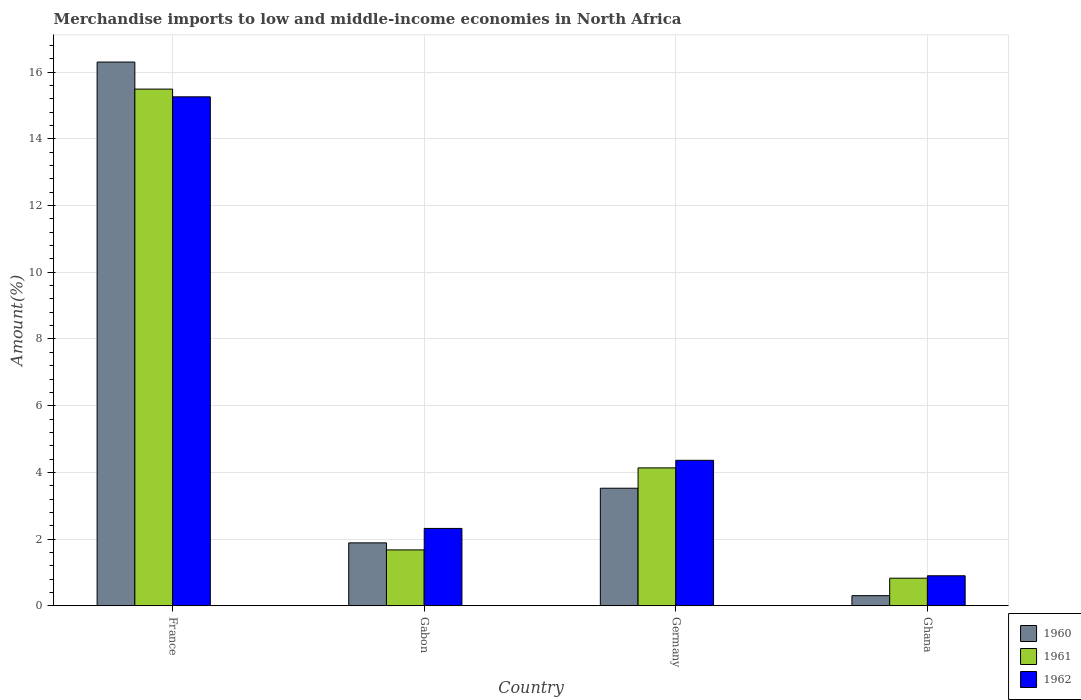How many groups of bars are there?
Provide a short and direct response. 4. Are the number of bars on each tick of the X-axis equal?
Keep it short and to the point. Yes. What is the label of the 2nd group of bars from the left?
Your response must be concise. Gabon. In how many cases, is the number of bars for a given country not equal to the number of legend labels?
Your response must be concise. 0. What is the percentage of amount earned from merchandise imports in 1962 in France?
Offer a terse response. 15.26. Across all countries, what is the maximum percentage of amount earned from merchandise imports in 1962?
Your answer should be compact. 15.26. Across all countries, what is the minimum percentage of amount earned from merchandise imports in 1960?
Ensure brevity in your answer.  0.3. In which country was the percentage of amount earned from merchandise imports in 1962 minimum?
Make the answer very short. Ghana. What is the total percentage of amount earned from merchandise imports in 1960 in the graph?
Make the answer very short. 22.02. What is the difference between the percentage of amount earned from merchandise imports in 1960 in Gabon and that in Ghana?
Offer a terse response. 1.58. What is the difference between the percentage of amount earned from merchandise imports in 1960 in Gabon and the percentage of amount earned from merchandise imports in 1961 in France?
Make the answer very short. -13.61. What is the average percentage of amount earned from merchandise imports in 1960 per country?
Give a very brief answer. 5.51. What is the difference between the percentage of amount earned from merchandise imports of/in 1960 and percentage of amount earned from merchandise imports of/in 1962 in Gabon?
Your answer should be compact. -0.43. In how many countries, is the percentage of amount earned from merchandise imports in 1960 greater than 14.4 %?
Ensure brevity in your answer.  1. What is the ratio of the percentage of amount earned from merchandise imports in 1960 in France to that in Germany?
Give a very brief answer. 4.62. Is the percentage of amount earned from merchandise imports in 1961 in France less than that in Ghana?
Ensure brevity in your answer.  No. What is the difference between the highest and the second highest percentage of amount earned from merchandise imports in 1961?
Your response must be concise. -2.46. What is the difference between the highest and the lowest percentage of amount earned from merchandise imports in 1960?
Provide a short and direct response. 16. In how many countries, is the percentage of amount earned from merchandise imports in 1962 greater than the average percentage of amount earned from merchandise imports in 1962 taken over all countries?
Offer a terse response. 1. Is the sum of the percentage of amount earned from merchandise imports in 1960 in France and Germany greater than the maximum percentage of amount earned from merchandise imports in 1961 across all countries?
Make the answer very short. Yes. What does the 3rd bar from the left in France represents?
Your answer should be compact. 1962. What does the 3rd bar from the right in Germany represents?
Keep it short and to the point. 1960. How many bars are there?
Your response must be concise. 12. How many countries are there in the graph?
Offer a terse response. 4. Are the values on the major ticks of Y-axis written in scientific E-notation?
Your response must be concise. No. Does the graph contain any zero values?
Your answer should be compact. No. Does the graph contain grids?
Your answer should be very brief. Yes. How are the legend labels stacked?
Your response must be concise. Vertical. What is the title of the graph?
Offer a very short reply. Merchandise imports to low and middle-income economies in North Africa. What is the label or title of the X-axis?
Your answer should be compact. Country. What is the label or title of the Y-axis?
Give a very brief answer. Amount(%). What is the Amount(%) of 1960 in France?
Keep it short and to the point. 16.3. What is the Amount(%) of 1961 in France?
Ensure brevity in your answer.  15.49. What is the Amount(%) in 1962 in France?
Your answer should be very brief. 15.26. What is the Amount(%) of 1960 in Gabon?
Keep it short and to the point. 1.89. What is the Amount(%) in 1961 in Gabon?
Your response must be concise. 1.68. What is the Amount(%) in 1962 in Gabon?
Your answer should be compact. 2.32. What is the Amount(%) of 1960 in Germany?
Make the answer very short. 3.53. What is the Amount(%) in 1961 in Germany?
Keep it short and to the point. 4.14. What is the Amount(%) of 1962 in Germany?
Keep it short and to the point. 4.36. What is the Amount(%) in 1960 in Ghana?
Offer a very short reply. 0.3. What is the Amount(%) in 1961 in Ghana?
Your answer should be very brief. 0.83. What is the Amount(%) in 1962 in Ghana?
Keep it short and to the point. 0.9. Across all countries, what is the maximum Amount(%) of 1960?
Provide a short and direct response. 16.3. Across all countries, what is the maximum Amount(%) of 1961?
Give a very brief answer. 15.49. Across all countries, what is the maximum Amount(%) of 1962?
Your answer should be compact. 15.26. Across all countries, what is the minimum Amount(%) in 1960?
Your answer should be very brief. 0.3. Across all countries, what is the minimum Amount(%) in 1961?
Make the answer very short. 0.83. Across all countries, what is the minimum Amount(%) of 1962?
Keep it short and to the point. 0.9. What is the total Amount(%) in 1960 in the graph?
Offer a very short reply. 22.02. What is the total Amount(%) of 1961 in the graph?
Keep it short and to the point. 22.13. What is the total Amount(%) of 1962 in the graph?
Make the answer very short. 22.84. What is the difference between the Amount(%) in 1960 in France and that in Gabon?
Offer a terse response. 14.42. What is the difference between the Amount(%) of 1961 in France and that in Gabon?
Make the answer very short. 13.82. What is the difference between the Amount(%) in 1962 in France and that in Gabon?
Your answer should be very brief. 12.94. What is the difference between the Amount(%) of 1960 in France and that in Germany?
Keep it short and to the point. 12.78. What is the difference between the Amount(%) of 1961 in France and that in Germany?
Offer a terse response. 11.36. What is the difference between the Amount(%) of 1962 in France and that in Germany?
Make the answer very short. 10.9. What is the difference between the Amount(%) of 1960 in France and that in Ghana?
Your answer should be compact. 16. What is the difference between the Amount(%) in 1961 in France and that in Ghana?
Provide a succinct answer. 14.67. What is the difference between the Amount(%) of 1962 in France and that in Ghana?
Your response must be concise. 14.36. What is the difference between the Amount(%) of 1960 in Gabon and that in Germany?
Provide a succinct answer. -1.64. What is the difference between the Amount(%) in 1961 in Gabon and that in Germany?
Provide a succinct answer. -2.46. What is the difference between the Amount(%) in 1962 in Gabon and that in Germany?
Your answer should be very brief. -2.04. What is the difference between the Amount(%) of 1960 in Gabon and that in Ghana?
Your answer should be compact. 1.58. What is the difference between the Amount(%) in 1961 in Gabon and that in Ghana?
Your answer should be very brief. 0.85. What is the difference between the Amount(%) in 1962 in Gabon and that in Ghana?
Provide a short and direct response. 1.42. What is the difference between the Amount(%) of 1960 in Germany and that in Ghana?
Keep it short and to the point. 3.22. What is the difference between the Amount(%) in 1961 in Germany and that in Ghana?
Your response must be concise. 3.31. What is the difference between the Amount(%) in 1962 in Germany and that in Ghana?
Offer a terse response. 3.46. What is the difference between the Amount(%) in 1960 in France and the Amount(%) in 1961 in Gabon?
Keep it short and to the point. 14.63. What is the difference between the Amount(%) in 1960 in France and the Amount(%) in 1962 in Gabon?
Give a very brief answer. 13.98. What is the difference between the Amount(%) of 1961 in France and the Amount(%) of 1962 in Gabon?
Ensure brevity in your answer.  13.17. What is the difference between the Amount(%) of 1960 in France and the Amount(%) of 1961 in Germany?
Give a very brief answer. 12.17. What is the difference between the Amount(%) of 1960 in France and the Amount(%) of 1962 in Germany?
Offer a very short reply. 11.94. What is the difference between the Amount(%) in 1961 in France and the Amount(%) in 1962 in Germany?
Give a very brief answer. 11.13. What is the difference between the Amount(%) in 1960 in France and the Amount(%) in 1961 in Ghana?
Provide a succinct answer. 15.48. What is the difference between the Amount(%) in 1960 in France and the Amount(%) in 1962 in Ghana?
Make the answer very short. 15.4. What is the difference between the Amount(%) of 1961 in France and the Amount(%) of 1962 in Ghana?
Ensure brevity in your answer.  14.59. What is the difference between the Amount(%) in 1960 in Gabon and the Amount(%) in 1961 in Germany?
Offer a terse response. -2.25. What is the difference between the Amount(%) of 1960 in Gabon and the Amount(%) of 1962 in Germany?
Keep it short and to the point. -2.48. What is the difference between the Amount(%) in 1961 in Gabon and the Amount(%) in 1962 in Germany?
Give a very brief answer. -2.69. What is the difference between the Amount(%) of 1960 in Gabon and the Amount(%) of 1961 in Ghana?
Give a very brief answer. 1.06. What is the difference between the Amount(%) in 1960 in Gabon and the Amount(%) in 1962 in Ghana?
Your answer should be compact. 0.99. What is the difference between the Amount(%) in 1961 in Gabon and the Amount(%) in 1962 in Ghana?
Ensure brevity in your answer.  0.78. What is the difference between the Amount(%) of 1960 in Germany and the Amount(%) of 1961 in Ghana?
Provide a succinct answer. 2.7. What is the difference between the Amount(%) of 1960 in Germany and the Amount(%) of 1962 in Ghana?
Your answer should be compact. 2.63. What is the difference between the Amount(%) of 1961 in Germany and the Amount(%) of 1962 in Ghana?
Your answer should be very brief. 3.23. What is the average Amount(%) of 1960 per country?
Offer a very short reply. 5.5. What is the average Amount(%) in 1961 per country?
Give a very brief answer. 5.53. What is the average Amount(%) in 1962 per country?
Offer a very short reply. 5.71. What is the difference between the Amount(%) in 1960 and Amount(%) in 1961 in France?
Ensure brevity in your answer.  0.81. What is the difference between the Amount(%) of 1960 and Amount(%) of 1962 in France?
Keep it short and to the point. 1.04. What is the difference between the Amount(%) of 1961 and Amount(%) of 1962 in France?
Provide a short and direct response. 0.23. What is the difference between the Amount(%) in 1960 and Amount(%) in 1961 in Gabon?
Offer a terse response. 0.21. What is the difference between the Amount(%) of 1960 and Amount(%) of 1962 in Gabon?
Provide a short and direct response. -0.43. What is the difference between the Amount(%) of 1961 and Amount(%) of 1962 in Gabon?
Your answer should be compact. -0.64. What is the difference between the Amount(%) in 1960 and Amount(%) in 1961 in Germany?
Keep it short and to the point. -0.61. What is the difference between the Amount(%) in 1960 and Amount(%) in 1962 in Germany?
Keep it short and to the point. -0.84. What is the difference between the Amount(%) of 1961 and Amount(%) of 1962 in Germany?
Offer a very short reply. -0.23. What is the difference between the Amount(%) of 1960 and Amount(%) of 1961 in Ghana?
Give a very brief answer. -0.52. What is the difference between the Amount(%) of 1960 and Amount(%) of 1962 in Ghana?
Give a very brief answer. -0.6. What is the difference between the Amount(%) in 1961 and Amount(%) in 1962 in Ghana?
Keep it short and to the point. -0.07. What is the ratio of the Amount(%) of 1960 in France to that in Gabon?
Give a very brief answer. 8.64. What is the ratio of the Amount(%) in 1961 in France to that in Gabon?
Provide a succinct answer. 9.24. What is the ratio of the Amount(%) of 1962 in France to that in Gabon?
Offer a very short reply. 6.58. What is the ratio of the Amount(%) in 1960 in France to that in Germany?
Give a very brief answer. 4.62. What is the ratio of the Amount(%) of 1961 in France to that in Germany?
Make the answer very short. 3.75. What is the ratio of the Amount(%) of 1962 in France to that in Germany?
Your response must be concise. 3.5. What is the ratio of the Amount(%) of 1960 in France to that in Ghana?
Keep it short and to the point. 53.67. What is the ratio of the Amount(%) in 1961 in France to that in Ghana?
Your answer should be compact. 18.72. What is the ratio of the Amount(%) in 1962 in France to that in Ghana?
Your answer should be very brief. 16.95. What is the ratio of the Amount(%) in 1960 in Gabon to that in Germany?
Keep it short and to the point. 0.54. What is the ratio of the Amount(%) of 1961 in Gabon to that in Germany?
Your answer should be compact. 0.41. What is the ratio of the Amount(%) of 1962 in Gabon to that in Germany?
Offer a terse response. 0.53. What is the ratio of the Amount(%) in 1960 in Gabon to that in Ghana?
Keep it short and to the point. 6.21. What is the ratio of the Amount(%) in 1961 in Gabon to that in Ghana?
Offer a very short reply. 2.03. What is the ratio of the Amount(%) in 1962 in Gabon to that in Ghana?
Your response must be concise. 2.58. What is the ratio of the Amount(%) of 1960 in Germany to that in Ghana?
Keep it short and to the point. 11.61. What is the ratio of the Amount(%) in 1961 in Germany to that in Ghana?
Offer a very short reply. 5. What is the ratio of the Amount(%) in 1962 in Germany to that in Ghana?
Offer a very short reply. 4.85. What is the difference between the highest and the second highest Amount(%) of 1960?
Offer a very short reply. 12.78. What is the difference between the highest and the second highest Amount(%) in 1961?
Provide a short and direct response. 11.36. What is the difference between the highest and the second highest Amount(%) of 1962?
Your response must be concise. 10.9. What is the difference between the highest and the lowest Amount(%) of 1960?
Provide a succinct answer. 16. What is the difference between the highest and the lowest Amount(%) of 1961?
Offer a terse response. 14.67. What is the difference between the highest and the lowest Amount(%) of 1962?
Your response must be concise. 14.36. 